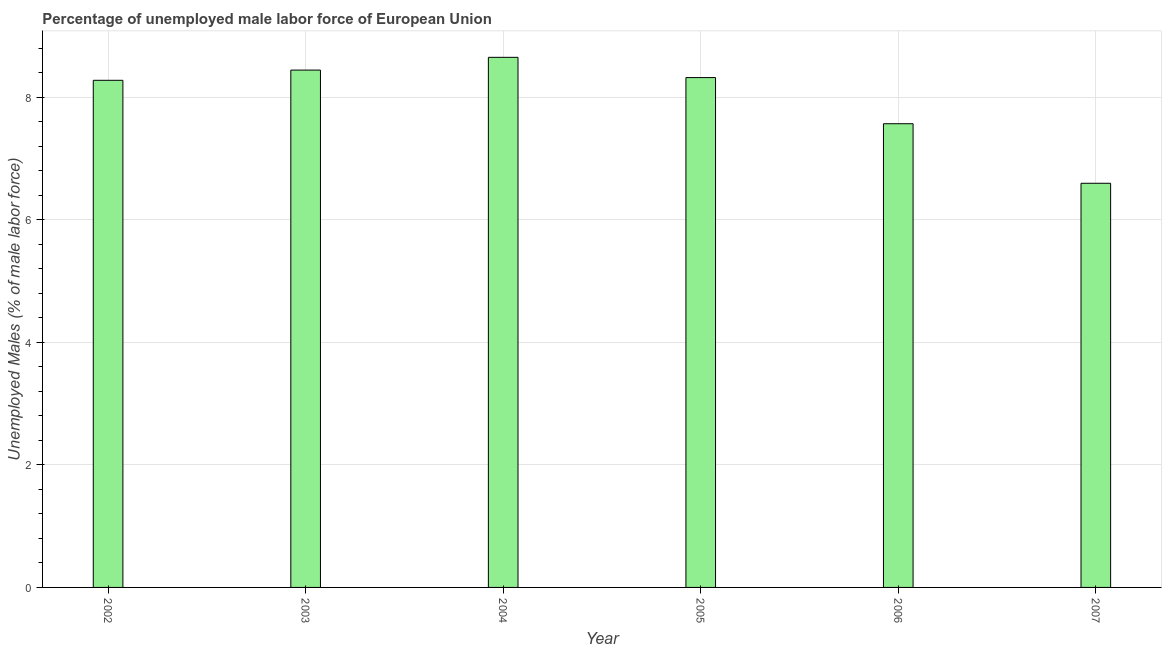Does the graph contain grids?
Give a very brief answer. Yes. What is the title of the graph?
Offer a terse response. Percentage of unemployed male labor force of European Union. What is the label or title of the X-axis?
Offer a terse response. Year. What is the label or title of the Y-axis?
Offer a very short reply. Unemployed Males (% of male labor force). What is the total unemployed male labour force in 2002?
Give a very brief answer. 8.28. Across all years, what is the maximum total unemployed male labour force?
Ensure brevity in your answer.  8.65. Across all years, what is the minimum total unemployed male labour force?
Give a very brief answer. 6.6. In which year was the total unemployed male labour force maximum?
Offer a terse response. 2004. In which year was the total unemployed male labour force minimum?
Your answer should be very brief. 2007. What is the sum of the total unemployed male labour force?
Your response must be concise. 47.86. What is the difference between the total unemployed male labour force in 2002 and 2004?
Your answer should be very brief. -0.38. What is the average total unemployed male labour force per year?
Keep it short and to the point. 7.98. What is the median total unemployed male labour force?
Ensure brevity in your answer.  8.3. What is the ratio of the total unemployed male labour force in 2006 to that in 2007?
Make the answer very short. 1.15. Is the total unemployed male labour force in 2003 less than that in 2006?
Offer a very short reply. No. What is the difference between the highest and the second highest total unemployed male labour force?
Your answer should be compact. 0.21. What is the difference between the highest and the lowest total unemployed male labour force?
Your answer should be very brief. 2.06. How many bars are there?
Provide a short and direct response. 6. How many years are there in the graph?
Offer a very short reply. 6. What is the difference between two consecutive major ticks on the Y-axis?
Provide a short and direct response. 2. Are the values on the major ticks of Y-axis written in scientific E-notation?
Your answer should be compact. No. What is the Unemployed Males (% of male labor force) in 2002?
Your response must be concise. 8.28. What is the Unemployed Males (% of male labor force) of 2003?
Ensure brevity in your answer.  8.44. What is the Unemployed Males (% of male labor force) of 2004?
Provide a short and direct response. 8.65. What is the Unemployed Males (% of male labor force) of 2005?
Provide a succinct answer. 8.32. What is the Unemployed Males (% of male labor force) of 2006?
Your response must be concise. 7.57. What is the Unemployed Males (% of male labor force) in 2007?
Give a very brief answer. 6.6. What is the difference between the Unemployed Males (% of male labor force) in 2002 and 2003?
Ensure brevity in your answer.  -0.17. What is the difference between the Unemployed Males (% of male labor force) in 2002 and 2004?
Keep it short and to the point. -0.37. What is the difference between the Unemployed Males (% of male labor force) in 2002 and 2005?
Your answer should be very brief. -0.04. What is the difference between the Unemployed Males (% of male labor force) in 2002 and 2006?
Your answer should be compact. 0.71. What is the difference between the Unemployed Males (% of male labor force) in 2002 and 2007?
Provide a short and direct response. 1.68. What is the difference between the Unemployed Males (% of male labor force) in 2003 and 2004?
Provide a succinct answer. -0.21. What is the difference between the Unemployed Males (% of male labor force) in 2003 and 2005?
Offer a terse response. 0.12. What is the difference between the Unemployed Males (% of male labor force) in 2003 and 2006?
Ensure brevity in your answer.  0.88. What is the difference between the Unemployed Males (% of male labor force) in 2003 and 2007?
Offer a terse response. 1.85. What is the difference between the Unemployed Males (% of male labor force) in 2004 and 2005?
Your answer should be very brief. 0.33. What is the difference between the Unemployed Males (% of male labor force) in 2004 and 2006?
Give a very brief answer. 1.08. What is the difference between the Unemployed Males (% of male labor force) in 2004 and 2007?
Offer a terse response. 2.06. What is the difference between the Unemployed Males (% of male labor force) in 2005 and 2006?
Your answer should be compact. 0.75. What is the difference between the Unemployed Males (% of male labor force) in 2005 and 2007?
Your answer should be compact. 1.72. What is the difference between the Unemployed Males (% of male labor force) in 2006 and 2007?
Offer a very short reply. 0.97. What is the ratio of the Unemployed Males (% of male labor force) in 2002 to that in 2005?
Provide a short and direct response. 0.99. What is the ratio of the Unemployed Males (% of male labor force) in 2002 to that in 2006?
Ensure brevity in your answer.  1.09. What is the ratio of the Unemployed Males (% of male labor force) in 2002 to that in 2007?
Your response must be concise. 1.25. What is the ratio of the Unemployed Males (% of male labor force) in 2003 to that in 2005?
Your response must be concise. 1.01. What is the ratio of the Unemployed Males (% of male labor force) in 2003 to that in 2006?
Provide a succinct answer. 1.12. What is the ratio of the Unemployed Males (% of male labor force) in 2003 to that in 2007?
Offer a terse response. 1.28. What is the ratio of the Unemployed Males (% of male labor force) in 2004 to that in 2006?
Your answer should be compact. 1.14. What is the ratio of the Unemployed Males (% of male labor force) in 2004 to that in 2007?
Keep it short and to the point. 1.31. What is the ratio of the Unemployed Males (% of male labor force) in 2005 to that in 2007?
Offer a terse response. 1.26. What is the ratio of the Unemployed Males (% of male labor force) in 2006 to that in 2007?
Provide a short and direct response. 1.15. 